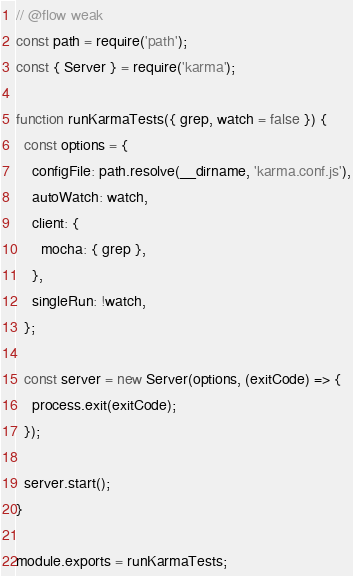Convert code to text. <code><loc_0><loc_0><loc_500><loc_500><_JavaScript_>// @flow weak
const path = require('path');
const { Server } = require('karma');

function runKarmaTests({ grep, watch = false }) {
  const options = {
    configFile: path.resolve(__dirname, 'karma.conf.js'),
    autoWatch: watch,
    client: {
      mocha: { grep },
    },
    singleRun: !watch,
  };

  const server = new Server(options, (exitCode) => {
    process.exit(exitCode);
  });

  server.start();
}

module.exports = runKarmaTests;
</code> 